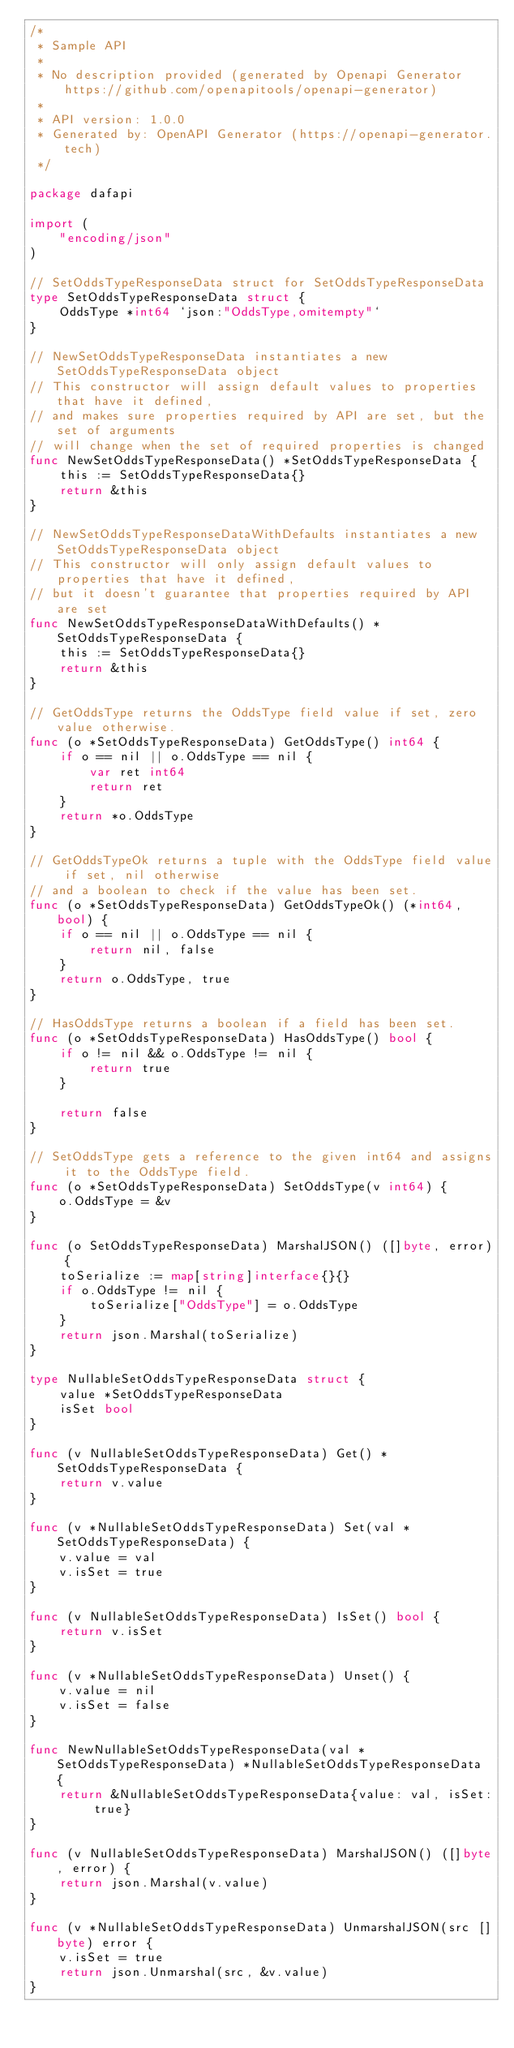<code> <loc_0><loc_0><loc_500><loc_500><_Go_>/*
 * Sample API
 *
 * No description provided (generated by Openapi Generator https://github.com/openapitools/openapi-generator)
 *
 * API version: 1.0.0
 * Generated by: OpenAPI Generator (https://openapi-generator.tech)
 */

package dafapi

import (
	"encoding/json"
)

// SetOddsTypeResponseData struct for SetOddsTypeResponseData
type SetOddsTypeResponseData struct {
	OddsType *int64 `json:"OddsType,omitempty"`
}

// NewSetOddsTypeResponseData instantiates a new SetOddsTypeResponseData object
// This constructor will assign default values to properties that have it defined,
// and makes sure properties required by API are set, but the set of arguments
// will change when the set of required properties is changed
func NewSetOddsTypeResponseData() *SetOddsTypeResponseData {
	this := SetOddsTypeResponseData{}
	return &this
}

// NewSetOddsTypeResponseDataWithDefaults instantiates a new SetOddsTypeResponseData object
// This constructor will only assign default values to properties that have it defined,
// but it doesn't guarantee that properties required by API are set
func NewSetOddsTypeResponseDataWithDefaults() *SetOddsTypeResponseData {
	this := SetOddsTypeResponseData{}
	return &this
}

// GetOddsType returns the OddsType field value if set, zero value otherwise.
func (o *SetOddsTypeResponseData) GetOddsType() int64 {
	if o == nil || o.OddsType == nil {
		var ret int64
		return ret
	}
	return *o.OddsType
}

// GetOddsTypeOk returns a tuple with the OddsType field value if set, nil otherwise
// and a boolean to check if the value has been set.
func (o *SetOddsTypeResponseData) GetOddsTypeOk() (*int64, bool) {
	if o == nil || o.OddsType == nil {
		return nil, false
	}
	return o.OddsType, true
}

// HasOddsType returns a boolean if a field has been set.
func (o *SetOddsTypeResponseData) HasOddsType() bool {
	if o != nil && o.OddsType != nil {
		return true
	}

	return false
}

// SetOddsType gets a reference to the given int64 and assigns it to the OddsType field.
func (o *SetOddsTypeResponseData) SetOddsType(v int64) {
	o.OddsType = &v
}

func (o SetOddsTypeResponseData) MarshalJSON() ([]byte, error) {
	toSerialize := map[string]interface{}{}
	if o.OddsType != nil {
		toSerialize["OddsType"] = o.OddsType
	}
	return json.Marshal(toSerialize)
}

type NullableSetOddsTypeResponseData struct {
	value *SetOddsTypeResponseData
	isSet bool
}

func (v NullableSetOddsTypeResponseData) Get() *SetOddsTypeResponseData {
	return v.value
}

func (v *NullableSetOddsTypeResponseData) Set(val *SetOddsTypeResponseData) {
	v.value = val
	v.isSet = true
}

func (v NullableSetOddsTypeResponseData) IsSet() bool {
	return v.isSet
}

func (v *NullableSetOddsTypeResponseData) Unset() {
	v.value = nil
	v.isSet = false
}

func NewNullableSetOddsTypeResponseData(val *SetOddsTypeResponseData) *NullableSetOddsTypeResponseData {
	return &NullableSetOddsTypeResponseData{value: val, isSet: true}
}

func (v NullableSetOddsTypeResponseData) MarshalJSON() ([]byte, error) {
	return json.Marshal(v.value)
}

func (v *NullableSetOddsTypeResponseData) UnmarshalJSON(src []byte) error {
	v.isSet = true
	return json.Unmarshal(src, &v.value)
}
</code> 